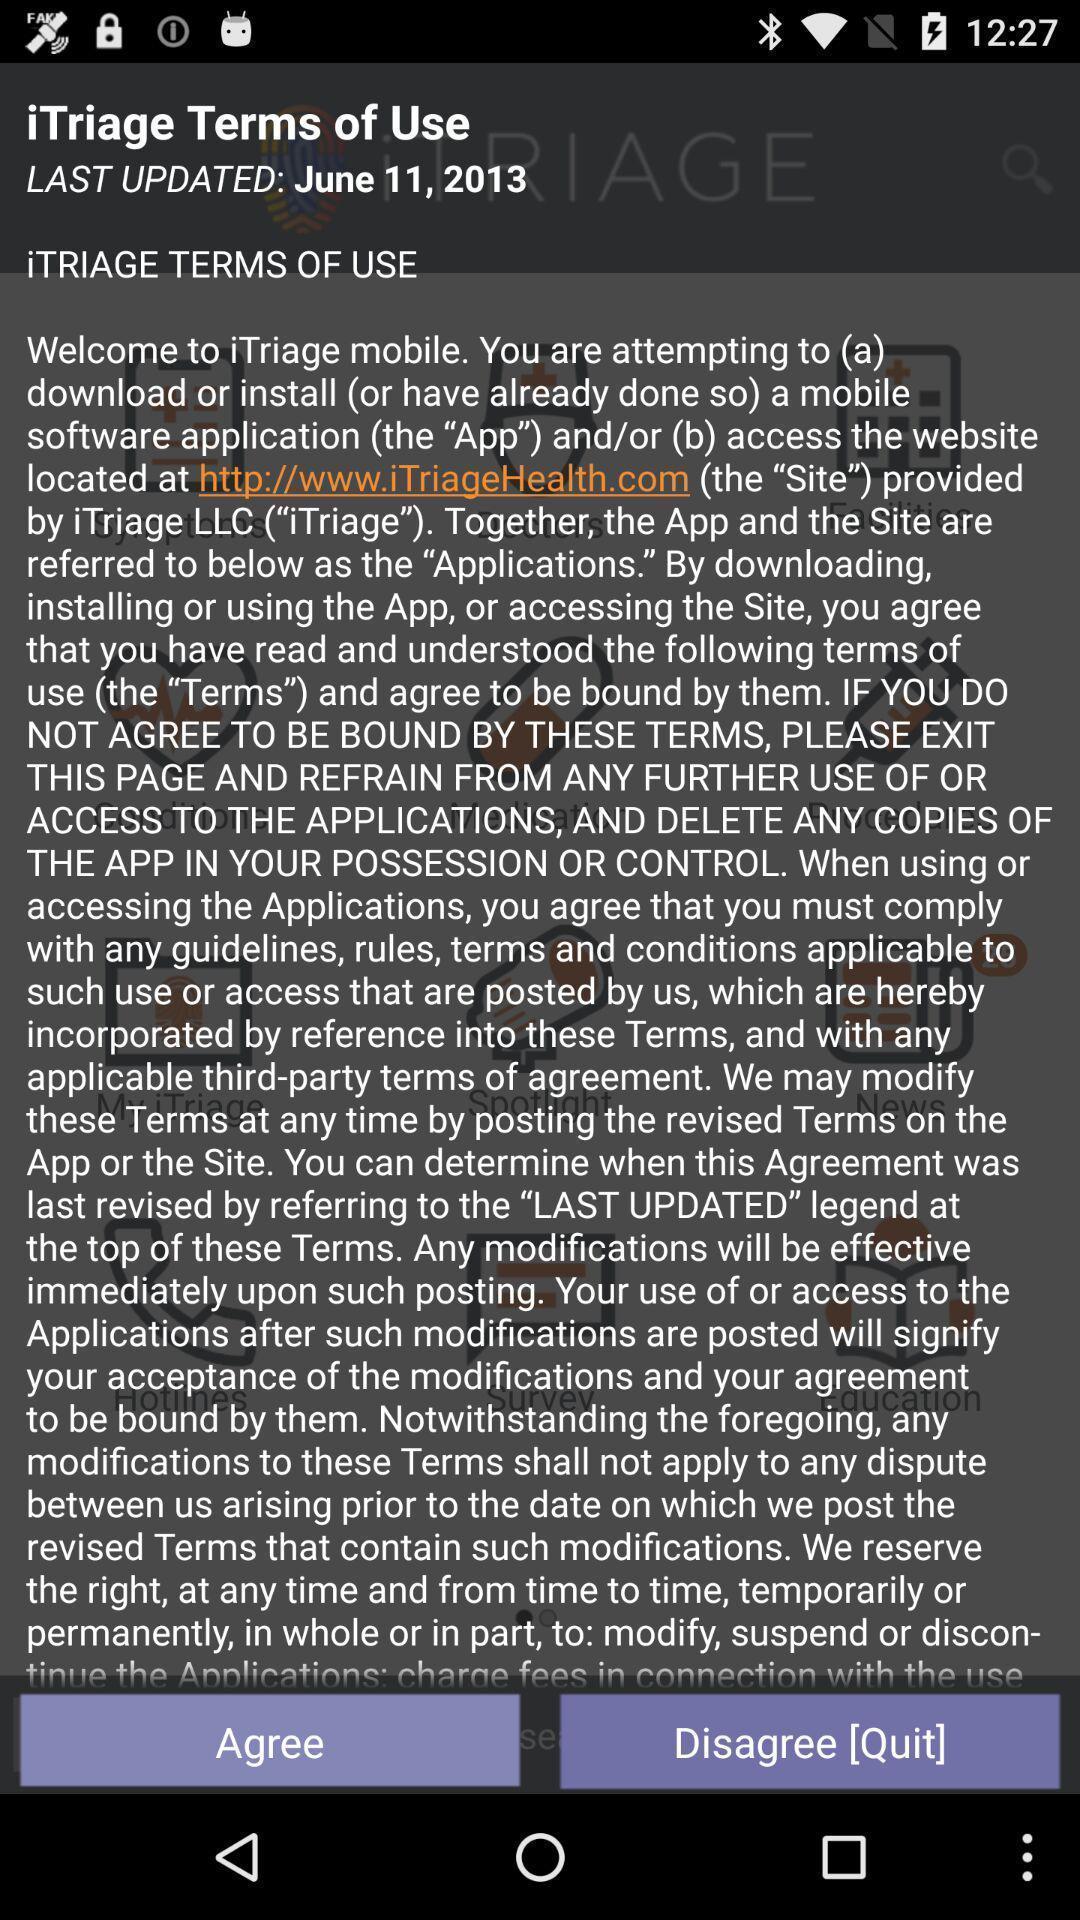Please provide a description for this image. Screen shows terms of use. 